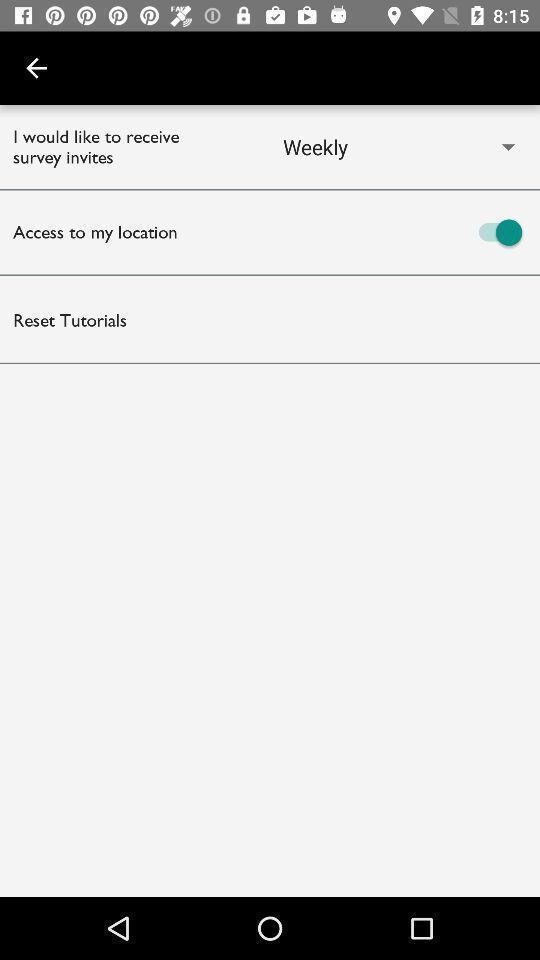Give me a summary of this screen capture. Showing with different options. 